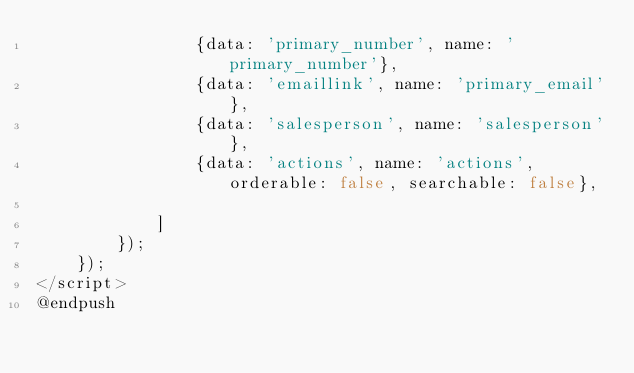Convert code to text. <code><loc_0><loc_0><loc_500><loc_500><_PHP_>                {data: 'primary_number', name: 'primary_number'},
                {data: 'emaillink', name: 'primary_email'},
                {data: 'salesperson', name: 'salesperson'},
                {data: 'actions', name: 'actions', orderable: false, searchable: false},

            ]
        });
    });
</script>
@endpush
</code> 